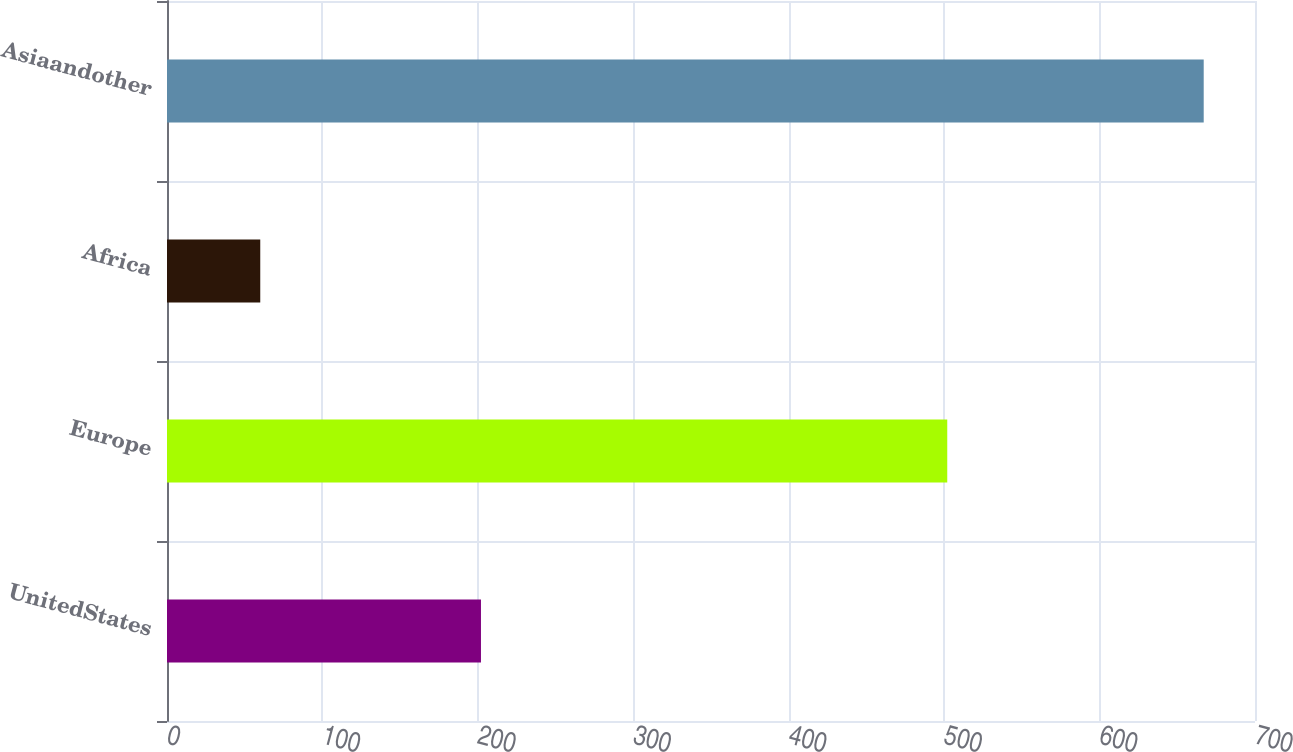Convert chart to OTSL. <chart><loc_0><loc_0><loc_500><loc_500><bar_chart><fcel>UnitedStates<fcel>Europe<fcel>Africa<fcel>Asiaandother<nl><fcel>202<fcel>502<fcel>60<fcel>667<nl></chart> 